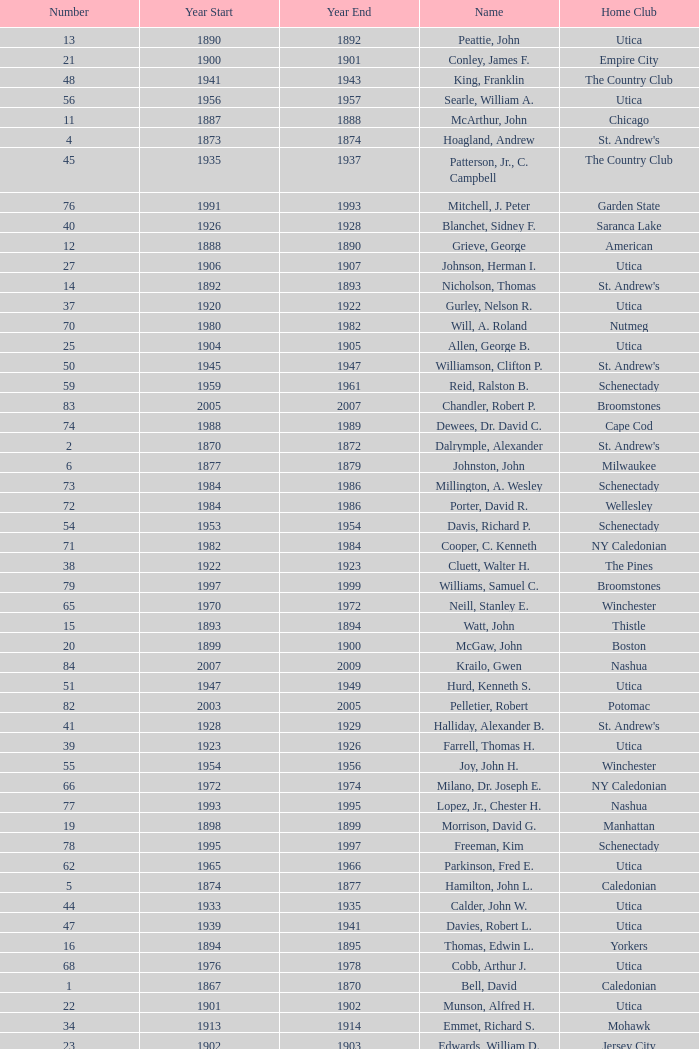Which Year Start has a Number of 28? 1907.0. 